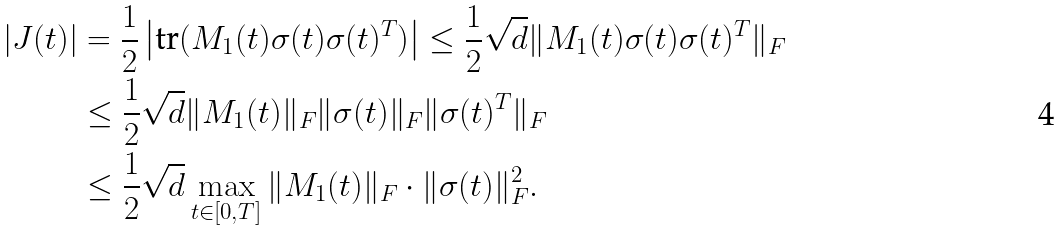Convert formula to latex. <formula><loc_0><loc_0><loc_500><loc_500>| J ( t ) | & = \frac { 1 } { 2 } \left | \text {tr} ( M _ { 1 } ( t ) \sigma ( t ) \sigma ( t ) ^ { T } ) \right | \leq \frac { 1 } { 2 } \sqrt { d } \| M _ { 1 } ( t ) \sigma ( t ) \sigma ( t ) ^ { T } \| _ { F } \\ & \leq \frac { 1 } { 2 } \sqrt { d } \| M _ { 1 } ( t ) \| _ { F } \| \sigma ( t ) \| _ { F } \| \sigma ( t ) ^ { T } \| _ { F } \\ & \leq \frac { 1 } { 2 } \sqrt { d } \max _ { t \in [ 0 , T ] } \| M _ { 1 } ( t ) \| _ { F } \cdot \| \sigma ( t ) \| ^ { 2 } _ { F } .</formula> 